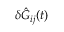Convert formula to latex. <formula><loc_0><loc_0><loc_500><loc_500>\delta \hat { G } _ { i j } ( t )</formula> 